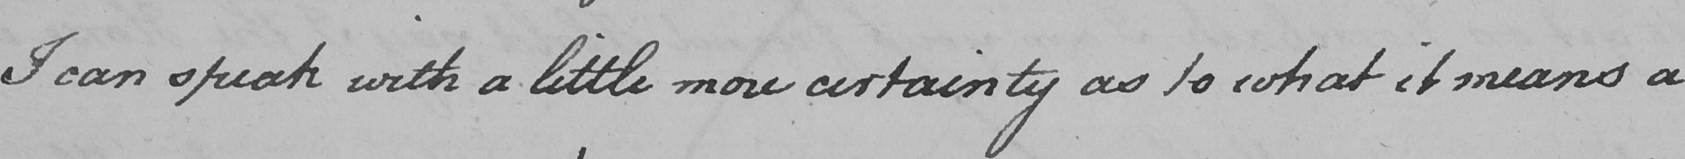Please transcribe the handwritten text in this image. I can speak with a little more certainty as to what it means a 